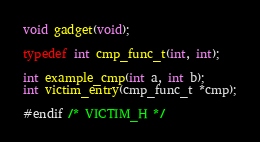<code> <loc_0><loc_0><loc_500><loc_500><_C_>void gadget(void);

typedef int cmp_func_t(int, int);

int example_cmp(int a, int b);
int victim_entry(cmp_func_t *cmp);

#endif /* VICTIM_H */
</code> 